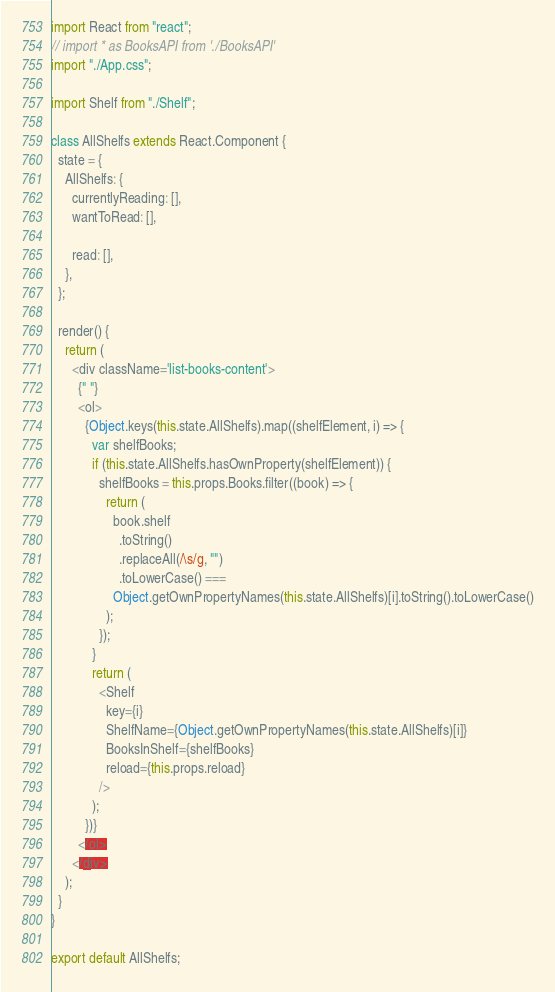Convert code to text. <code><loc_0><loc_0><loc_500><loc_500><_JavaScript_>import React from "react";
// import * as BooksAPI from './BooksAPI'
import "./App.css";

import Shelf from "./Shelf";

class AllShelfs extends React.Component {
  state = {
    AllShelfs: {
      currentlyReading: [],
      wantToRead: [],

      read: [],
    },
  };

  render() {
    return (
      <div className='list-books-content'>
        {" "}
        <ol>
          {Object.keys(this.state.AllShelfs).map((shelfElement, i) => {
            var shelfBooks;
            if (this.state.AllShelfs.hasOwnProperty(shelfElement)) {
              shelfBooks = this.props.Books.filter((book) => {
                return (
                  book.shelf
                    .toString()
                    .replaceAll(/\s/g, "")
                    .toLowerCase() ===
                  Object.getOwnPropertyNames(this.state.AllShelfs)[i].toString().toLowerCase()
                );
              });
            }
            return (
              <Shelf
                key={i}
                ShelfName={Object.getOwnPropertyNames(this.state.AllShelfs)[i]}
                BooksInShelf={shelfBooks}
                reload={this.props.reload}
              />
            );
          })}
        </ol>
      </div>
    );
  }
}

export default AllShelfs;
</code> 